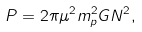<formula> <loc_0><loc_0><loc_500><loc_500>P = 2 \pi \mu ^ { 2 } m _ { p } ^ { 2 } G N ^ { 2 } ,</formula> 